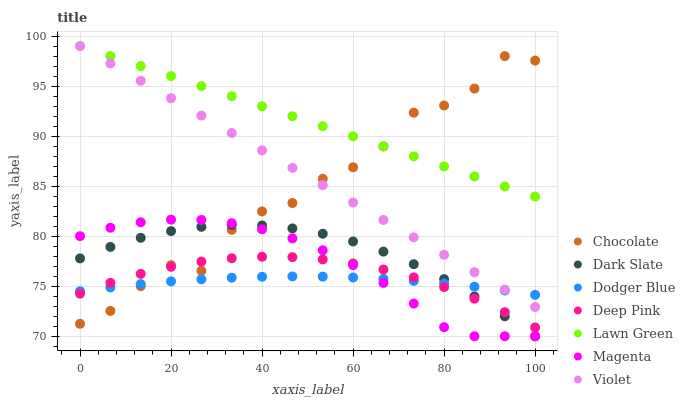Does Dodger Blue have the minimum area under the curve?
Answer yes or no. Yes. Does Lawn Green have the maximum area under the curve?
Answer yes or no. Yes. Does Deep Pink have the minimum area under the curve?
Answer yes or no. No. Does Deep Pink have the maximum area under the curve?
Answer yes or no. No. Is Lawn Green the smoothest?
Answer yes or no. Yes. Is Chocolate the roughest?
Answer yes or no. Yes. Is Deep Pink the smoothest?
Answer yes or no. No. Is Deep Pink the roughest?
Answer yes or no. No. Does Dark Slate have the lowest value?
Answer yes or no. Yes. Does Deep Pink have the lowest value?
Answer yes or no. No. Does Violet have the highest value?
Answer yes or no. Yes. Does Deep Pink have the highest value?
Answer yes or no. No. Is Dark Slate less than Lawn Green?
Answer yes or no. Yes. Is Violet greater than Magenta?
Answer yes or no. Yes. Does Dodger Blue intersect Violet?
Answer yes or no. Yes. Is Dodger Blue less than Violet?
Answer yes or no. No. Is Dodger Blue greater than Violet?
Answer yes or no. No. Does Dark Slate intersect Lawn Green?
Answer yes or no. No. 